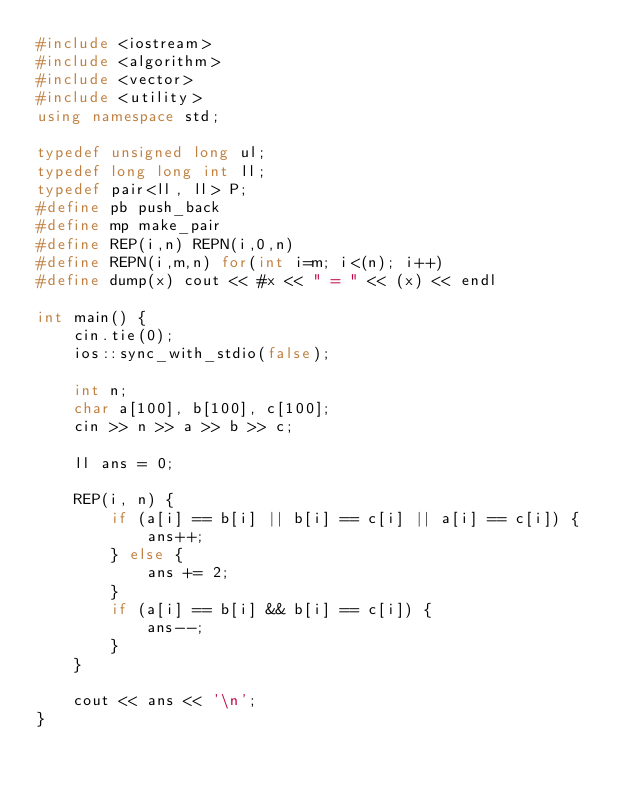<code> <loc_0><loc_0><loc_500><loc_500><_C++_>#include <iostream>
#include <algorithm>
#include <vector>
#include <utility>
using namespace std;

typedef unsigned long ul;
typedef long long int ll;
typedef pair<ll, ll> P;
#define pb push_back
#define mp make_pair
#define REP(i,n) REPN(i,0,n)
#define REPN(i,m,n) for(int i=m; i<(n); i++)
#define dump(x) cout << #x << " = " << (x) << endl

int main() {
    cin.tie(0);
    ios::sync_with_stdio(false);

    int n;
    char a[100], b[100], c[100];
    cin >> n >> a >> b >> c;

    ll ans = 0;

    REP(i, n) {
        if (a[i] == b[i] || b[i] == c[i] || a[i] == c[i]) {
            ans++;
        } else {
            ans += 2;
        }
        if (a[i] == b[i] && b[i] == c[i]) {
            ans--;
        }
    }

    cout << ans << '\n';
}
</code> 